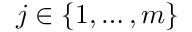Convert formula to latex. <formula><loc_0><loc_0><loc_500><loc_500>j \in \{ 1 , \dots , m \}</formula> 